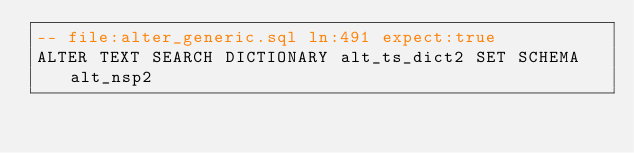<code> <loc_0><loc_0><loc_500><loc_500><_SQL_>-- file:alter_generic.sql ln:491 expect:true
ALTER TEXT SEARCH DICTIONARY alt_ts_dict2 SET SCHEMA alt_nsp2
</code> 